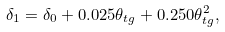<formula> <loc_0><loc_0><loc_500><loc_500>\delta _ { 1 } = \delta _ { 0 } + 0 . 0 2 5 \theta _ { t g } + 0 . 2 5 0 \theta _ { t g } ^ { 2 } ,</formula> 